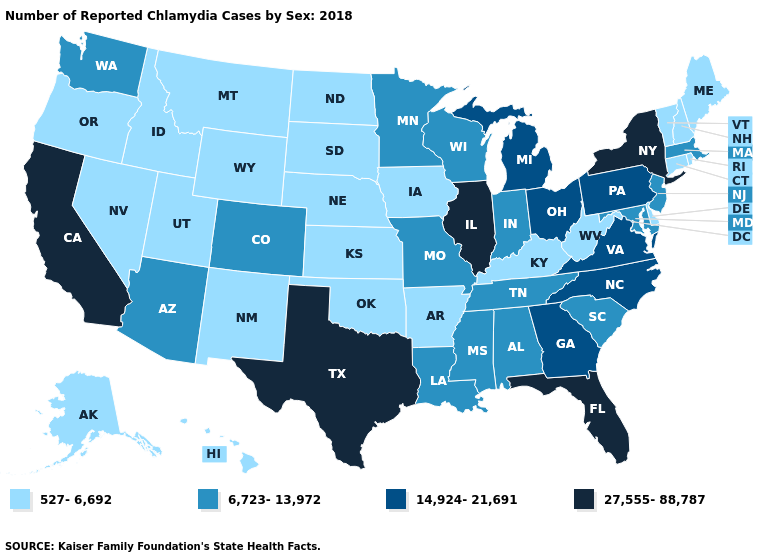Among the states that border New Mexico , which have the highest value?
Answer briefly. Texas. Name the states that have a value in the range 6,723-13,972?
Be succinct. Alabama, Arizona, Colorado, Indiana, Louisiana, Maryland, Massachusetts, Minnesota, Mississippi, Missouri, New Jersey, South Carolina, Tennessee, Washington, Wisconsin. Among the states that border Arkansas , which have the lowest value?
Write a very short answer. Oklahoma. What is the value of Ohio?
Answer briefly. 14,924-21,691. Name the states that have a value in the range 27,555-88,787?
Answer briefly. California, Florida, Illinois, New York, Texas. What is the lowest value in the West?
Quick response, please. 527-6,692. Does the first symbol in the legend represent the smallest category?
Write a very short answer. Yes. Name the states that have a value in the range 14,924-21,691?
Give a very brief answer. Georgia, Michigan, North Carolina, Ohio, Pennsylvania, Virginia. Name the states that have a value in the range 527-6,692?
Be succinct. Alaska, Arkansas, Connecticut, Delaware, Hawaii, Idaho, Iowa, Kansas, Kentucky, Maine, Montana, Nebraska, Nevada, New Hampshire, New Mexico, North Dakota, Oklahoma, Oregon, Rhode Island, South Dakota, Utah, Vermont, West Virginia, Wyoming. Name the states that have a value in the range 6,723-13,972?
Give a very brief answer. Alabama, Arizona, Colorado, Indiana, Louisiana, Maryland, Massachusetts, Minnesota, Mississippi, Missouri, New Jersey, South Carolina, Tennessee, Washington, Wisconsin. What is the lowest value in the USA?
Short answer required. 527-6,692. What is the value of Oregon?
Quick response, please. 527-6,692. Which states have the lowest value in the South?
Answer briefly. Arkansas, Delaware, Kentucky, Oklahoma, West Virginia. What is the value of Iowa?
Write a very short answer. 527-6,692. Does New York have the highest value in the USA?
Write a very short answer. Yes. 